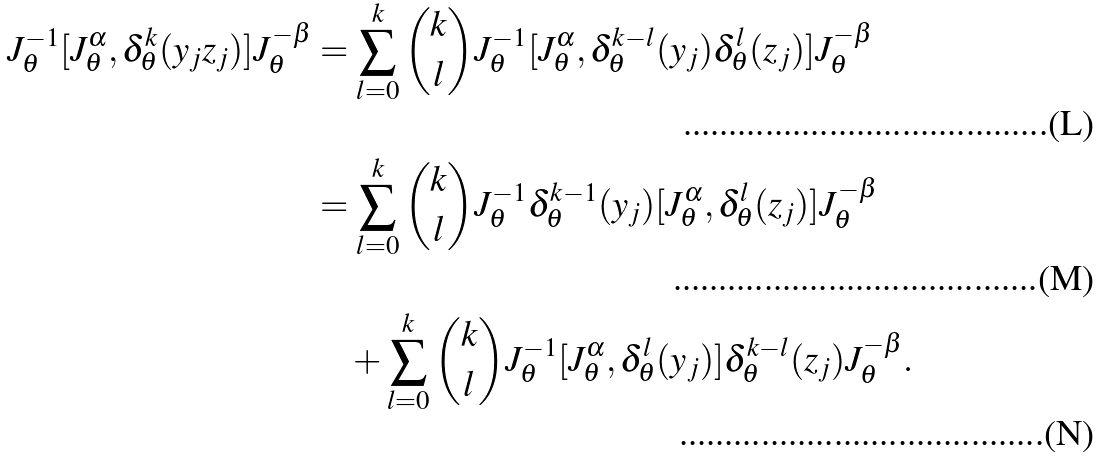<formula> <loc_0><loc_0><loc_500><loc_500>J _ { \theta } ^ { - 1 } [ J _ { \theta } ^ { \alpha } , \delta _ { \theta } ^ { k } ( y _ { j } z _ { j } ) ] J _ { \theta } ^ { - \beta } & = \sum _ { l = 0 } ^ { k } \binom { k } { l } J _ { \theta } ^ { - 1 } [ J _ { \theta } ^ { \alpha } , \delta _ { \theta } ^ { k - l } ( y _ { j } ) \delta _ { \theta } ^ { l } ( z _ { j } ) ] J _ { \theta } ^ { - \beta } \\ & = \sum _ { l = 0 } ^ { k } \binom { k } { l } J _ { \theta } ^ { - 1 } \delta _ { \theta } ^ { k - 1 } ( y _ { j } ) [ J _ { \theta } ^ { \alpha } , \delta _ { \theta } ^ { l } ( z _ { j } ) ] J _ { \theta } ^ { - \beta } \\ & \quad + \sum _ { l = 0 } ^ { k } \binom { k } { l } J _ { \theta } ^ { - 1 } [ J _ { \theta } ^ { \alpha } , \delta _ { \theta } ^ { l } ( y _ { j } ) ] \delta _ { \theta } ^ { k - l } ( z _ { j } ) J _ { \theta } ^ { - \beta } .</formula> 